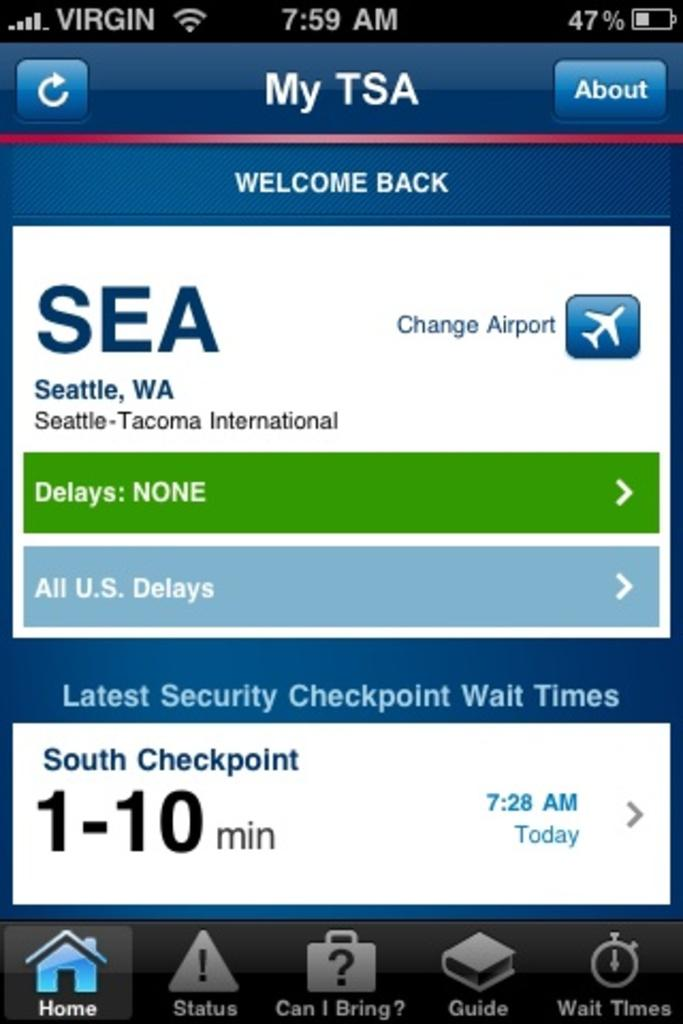<image>
Summarize the visual content of the image. A welcome screen for TSA from Seattle on a device. 